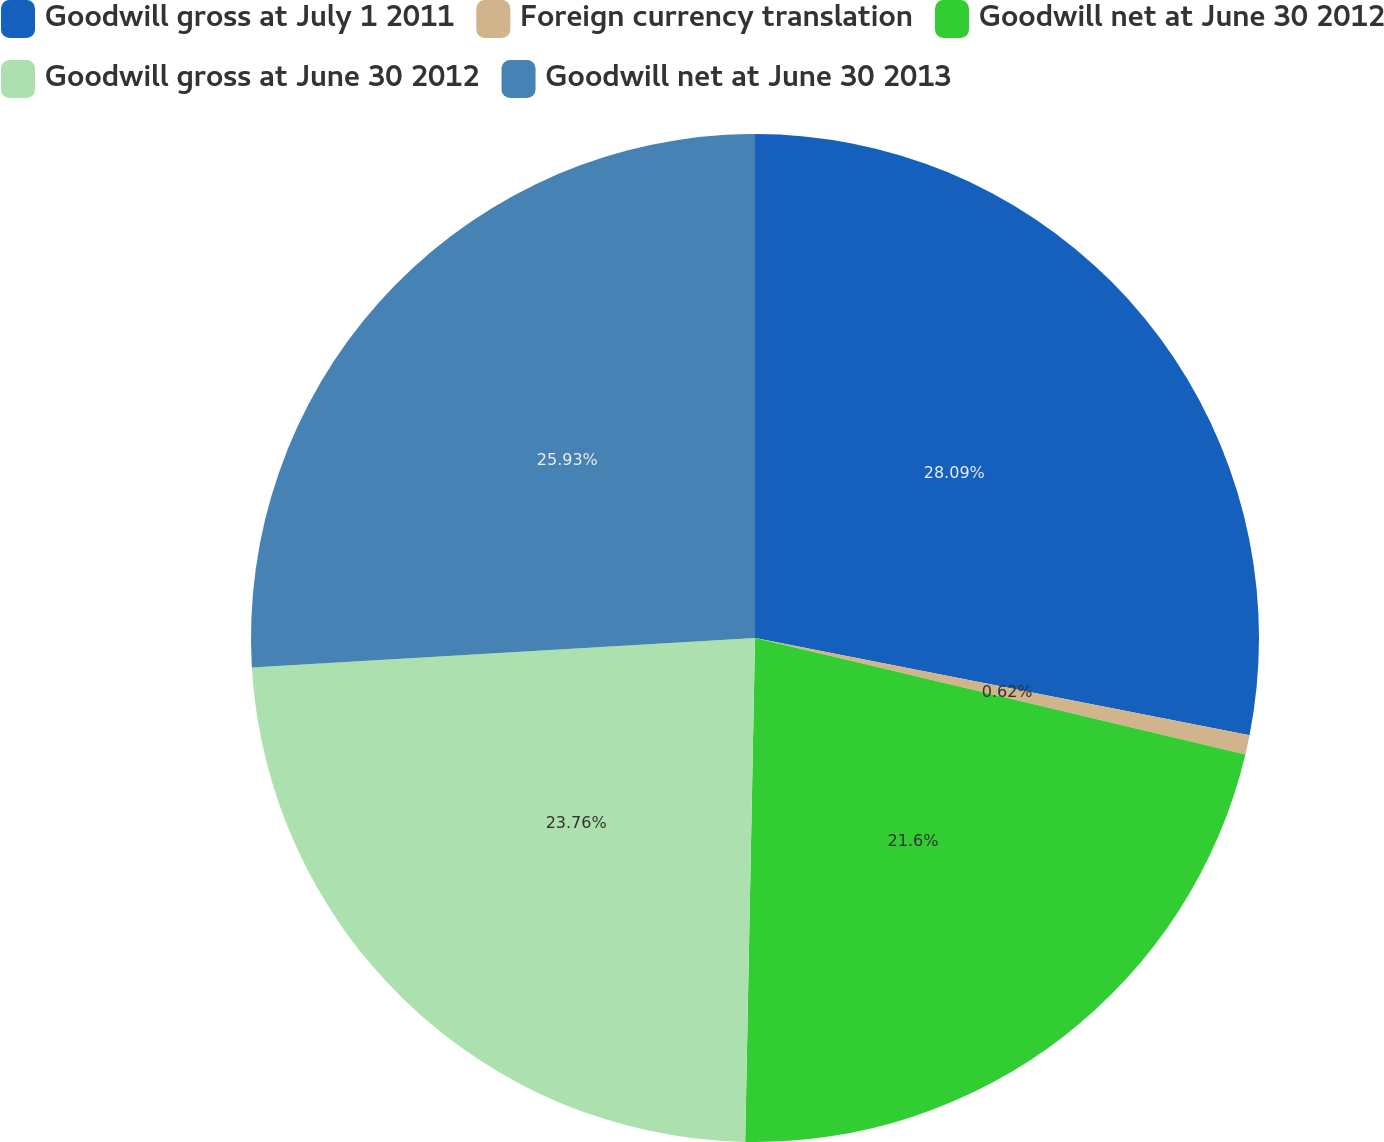Convert chart to OTSL. <chart><loc_0><loc_0><loc_500><loc_500><pie_chart><fcel>Goodwill gross at July 1 2011<fcel>Foreign currency translation<fcel>Goodwill net at June 30 2012<fcel>Goodwill gross at June 30 2012<fcel>Goodwill net at June 30 2013<nl><fcel>28.09%<fcel>0.62%<fcel>21.6%<fcel>23.76%<fcel>25.93%<nl></chart> 